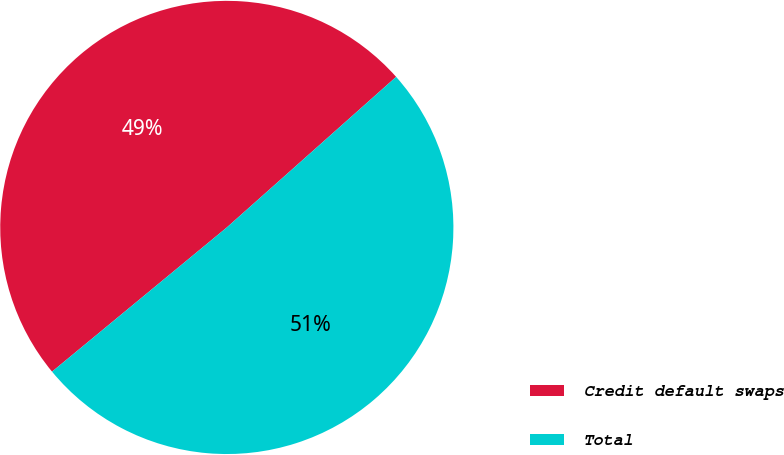<chart> <loc_0><loc_0><loc_500><loc_500><pie_chart><fcel>Credit default swaps<fcel>Total<nl><fcel>49.41%<fcel>50.59%<nl></chart> 